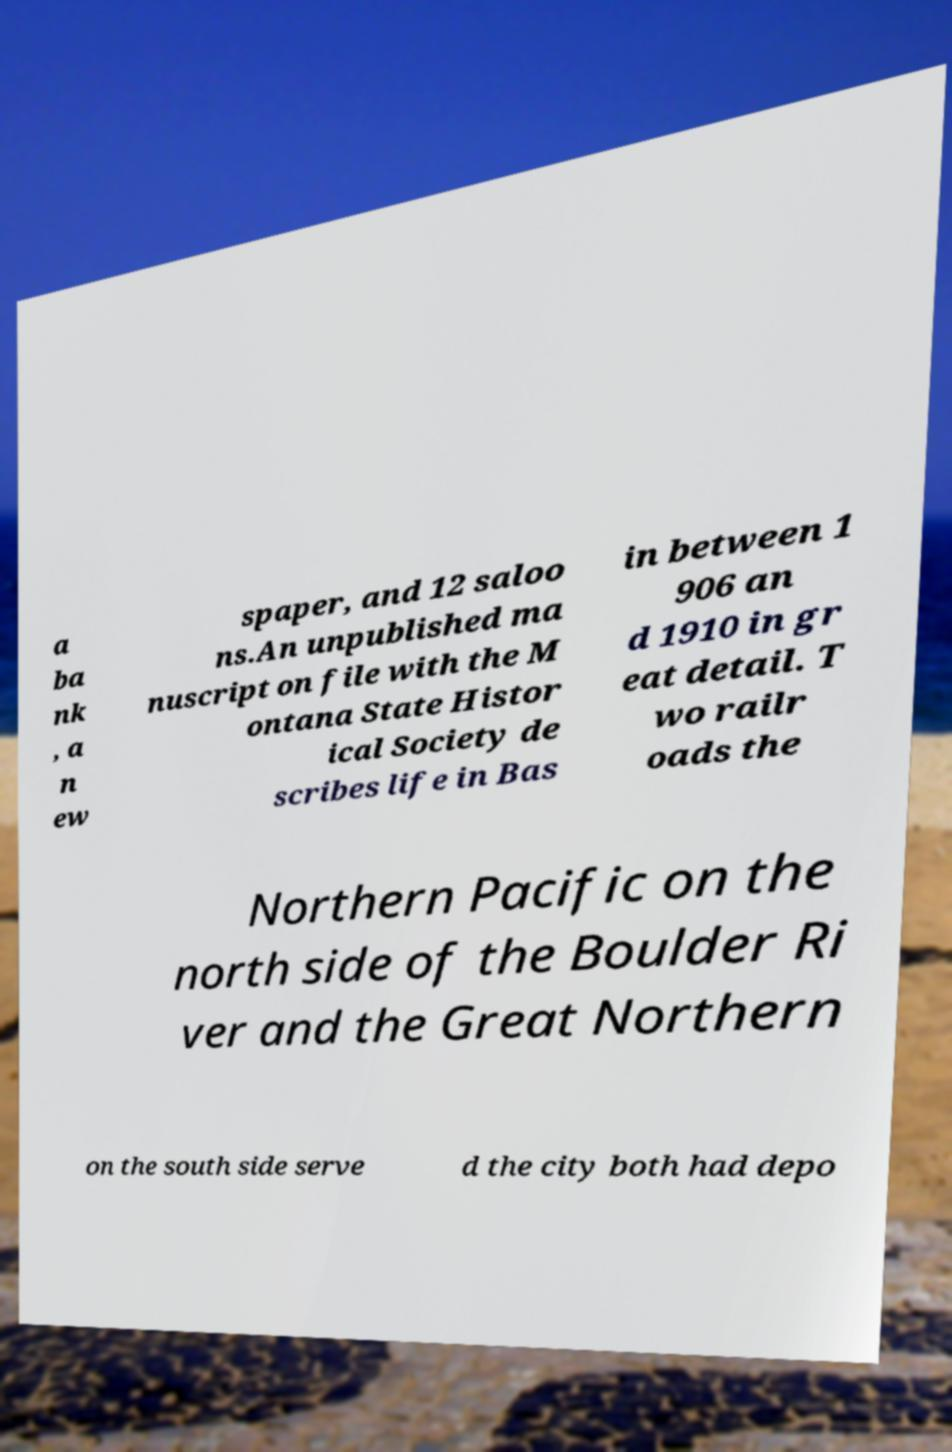For documentation purposes, I need the text within this image transcribed. Could you provide that? a ba nk , a n ew spaper, and 12 saloo ns.An unpublished ma nuscript on file with the M ontana State Histor ical Society de scribes life in Bas in between 1 906 an d 1910 in gr eat detail. T wo railr oads the Northern Pacific on the north side of the Boulder Ri ver and the Great Northern on the south side serve d the city both had depo 